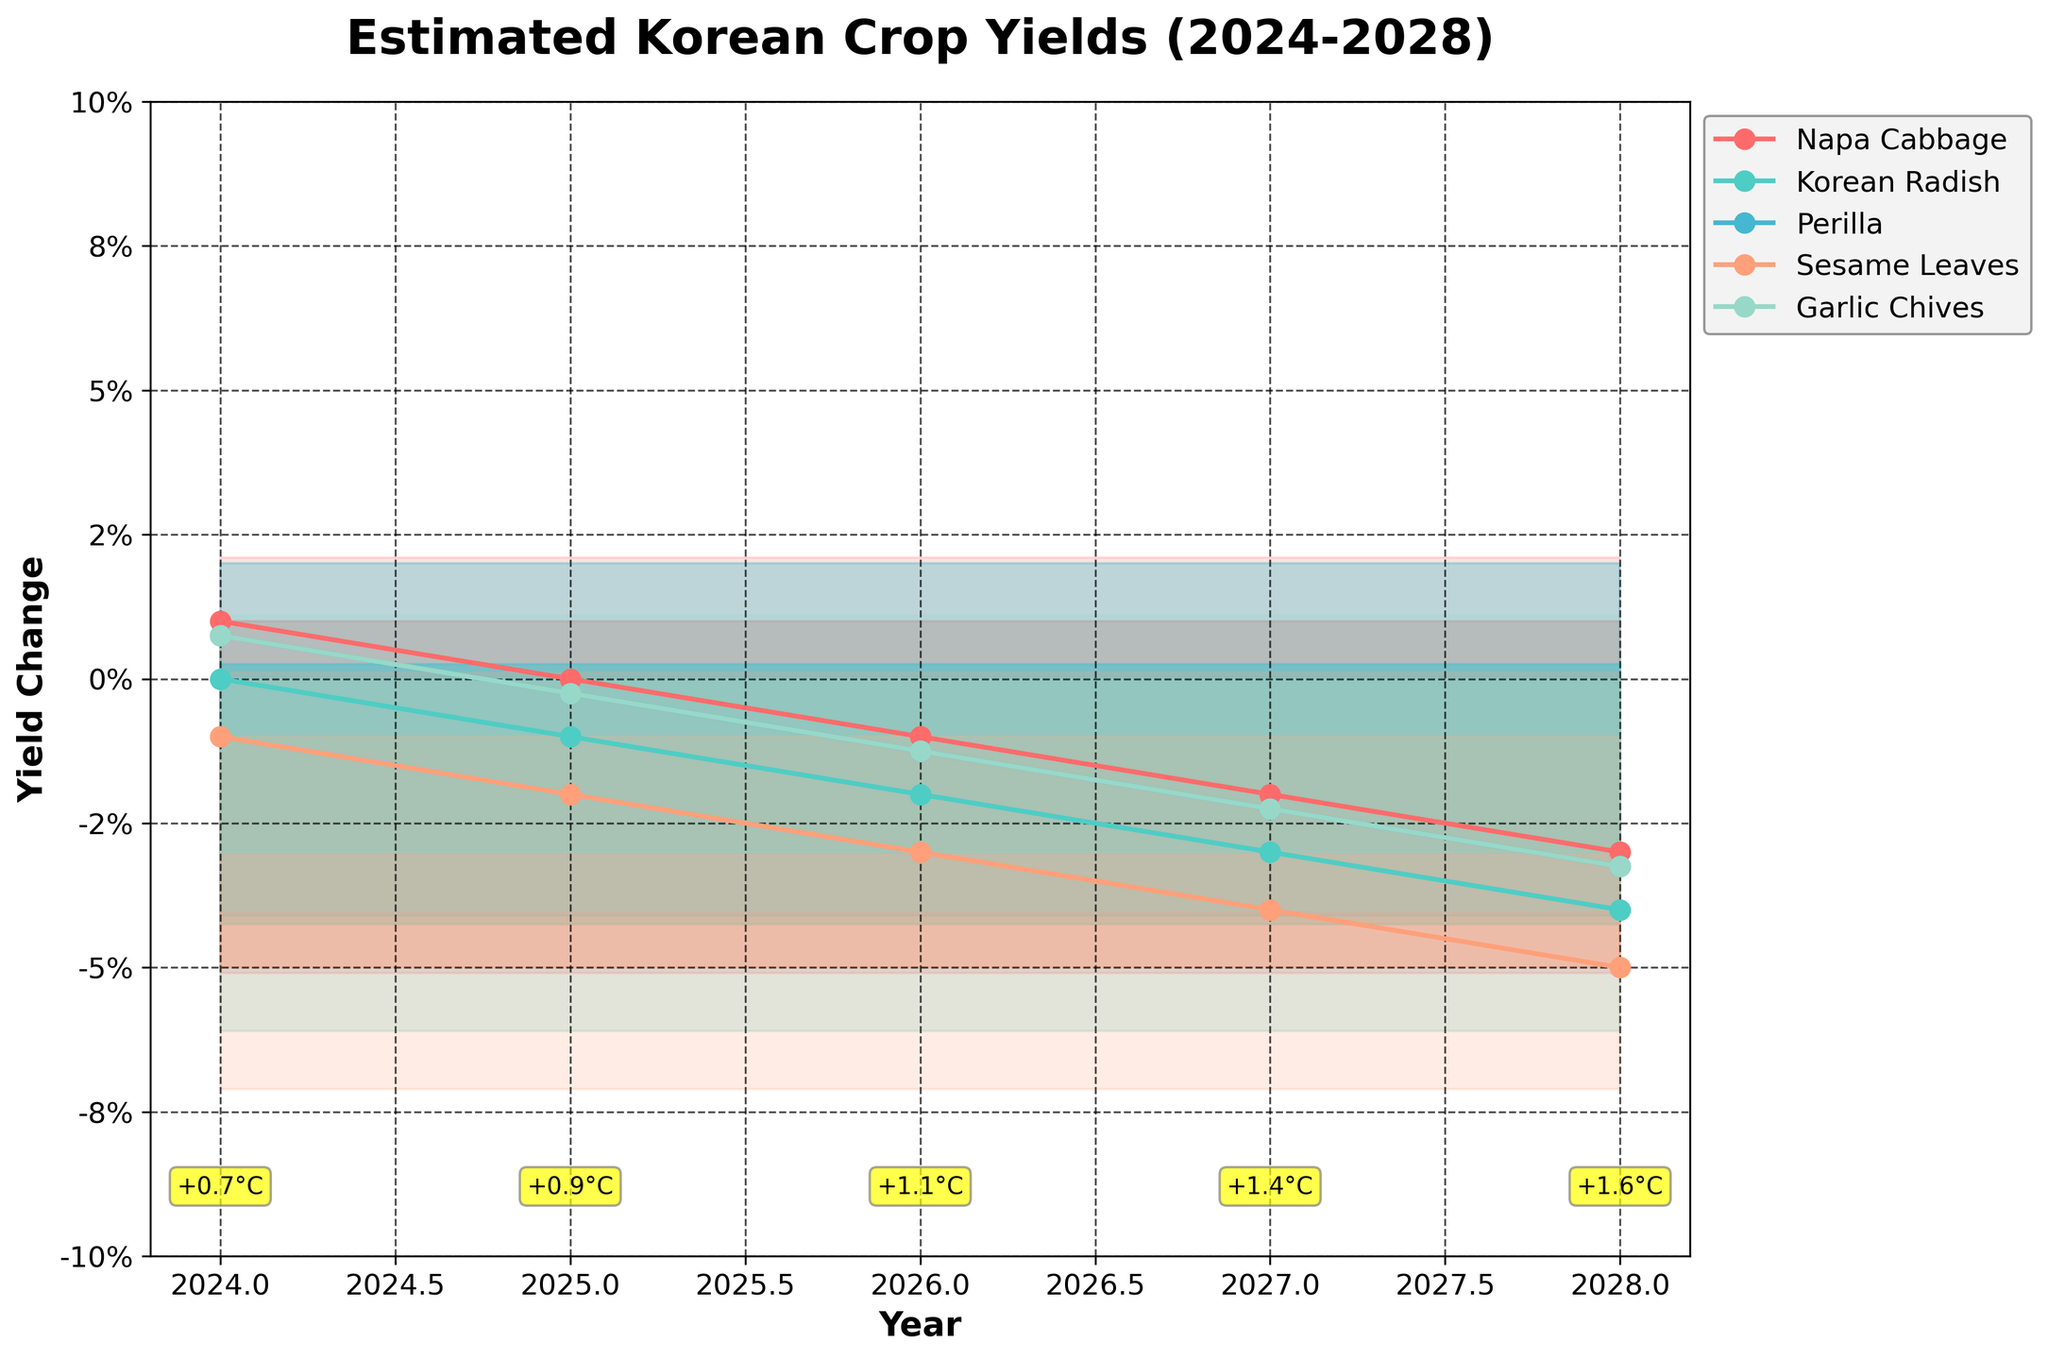What is the title of the figure? The title of the figure is centered at the top and in bold font. It reads "Estimated Korean Crop Yields (2024-2028)."
Answer: Estimated Korean Crop Yields (2024-2028) Which crop shows the most considerable yield decrease in summer 2028? To answer this, we look at the fan chart and find summer 2028. The plot shows each crop’s yield change indicated with different colors. The crop with the sharpest decline is depicted with the darkest shade of red, which is Korean Radish.
Answer: Korean Radish In which year is the average temperature change the highest? The temperature changes are annotated at the bottom near each year. By comparing these annotations, 2028 shows the highest temperature change of +2.4°C in summer.
Answer: 2028 How does the yield of Napa Cabbage in spring 2025 compare to its yield in spring 2024? From the fan chart, compare the points for Napa Cabbage (identified by its color) in spring 2024 and spring 2025. In spring 2024, the yield change is +2%, whereas in spring 2025, it is +1%. So, the yield change decreased by 1%.
Answer: Decreased by 1% Which season shows the most substantial negative impact on crop yields over the years? Examine the trend lines for each crop and season. The most significant negative impact is seen consistently during the summer months, where all crops show the greatest yield decreases.
Answer: Summer What is the percentile range shown for yield changes? The fan chart shows different shades indicating percentile ranges, with lighter shades representing more central percentiles. The percentiles used are 10th to 90th.
Answer: 10th to 90th Which crop yield remains the most stable throughout the five years? By observing the trend lines for each crop, the crop with the least fluctuation is Garlic Chives, which shows slight variations compared to others.
Answer: Garlic Chives What is the predicted yield change for Perilla in winter 2027? Locate the winter 2027 on the fan chart and find the associated line for Perilla by its color. The yield change is listed as -1%.
Answer: -1% Which year shows the least variability in crop yields? Variability is indicated by the width of the shaded areas around the median lines. The year with the narrowest shading, indicating the least variability, is 2028.
Answer: 2028 